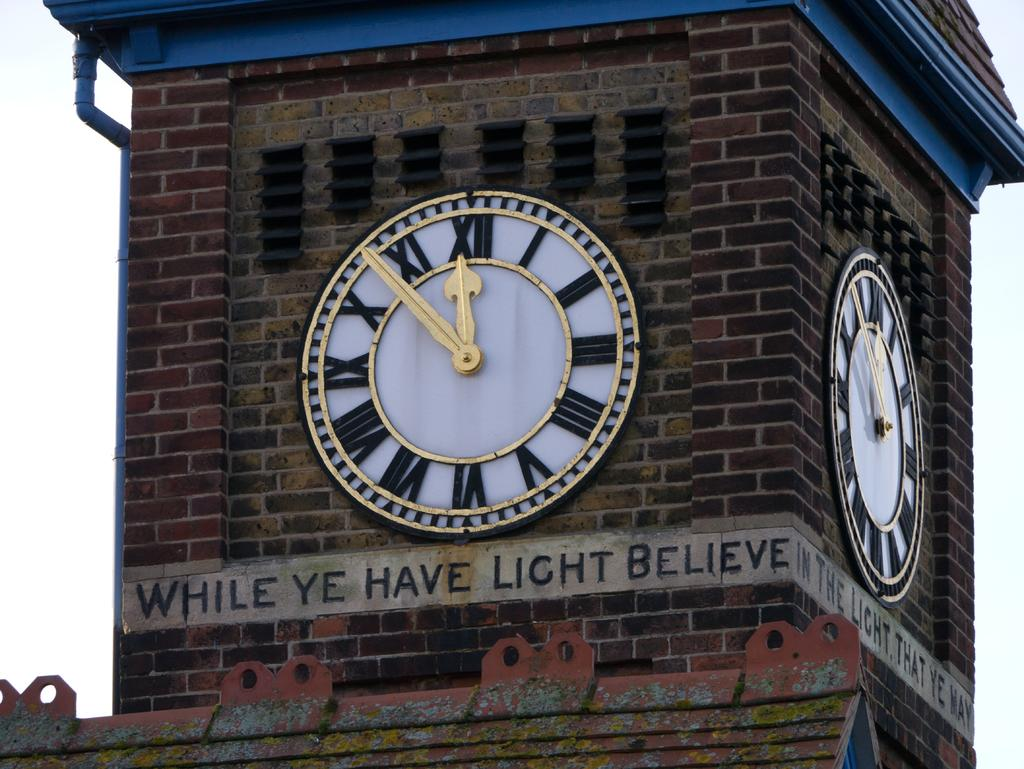<image>
Write a terse but informative summary of the picture. Sign below a clock that says While ye have light believe. 